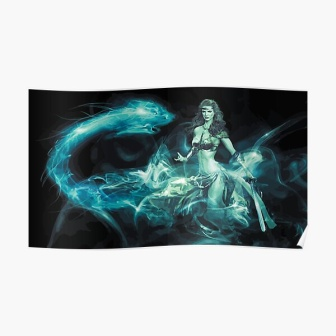Describe the emotions conveyed by the woman in the image. The woman in the image exudes a profound sense of calm and resilience. Her serene expression suggests composure amidst chaos, as if she is a beacon of tranquility navigating through turmoil. The grip on her sword and the swirling blue smoke surrounding her hint at underlying strength and readiness, portraying a character that is both powerful and unyielding. 